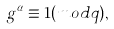Convert formula to latex. <formula><loc_0><loc_0><loc_500><loc_500>g ^ { \alpha } \equiv 1 ( m o d q ) ,</formula> 